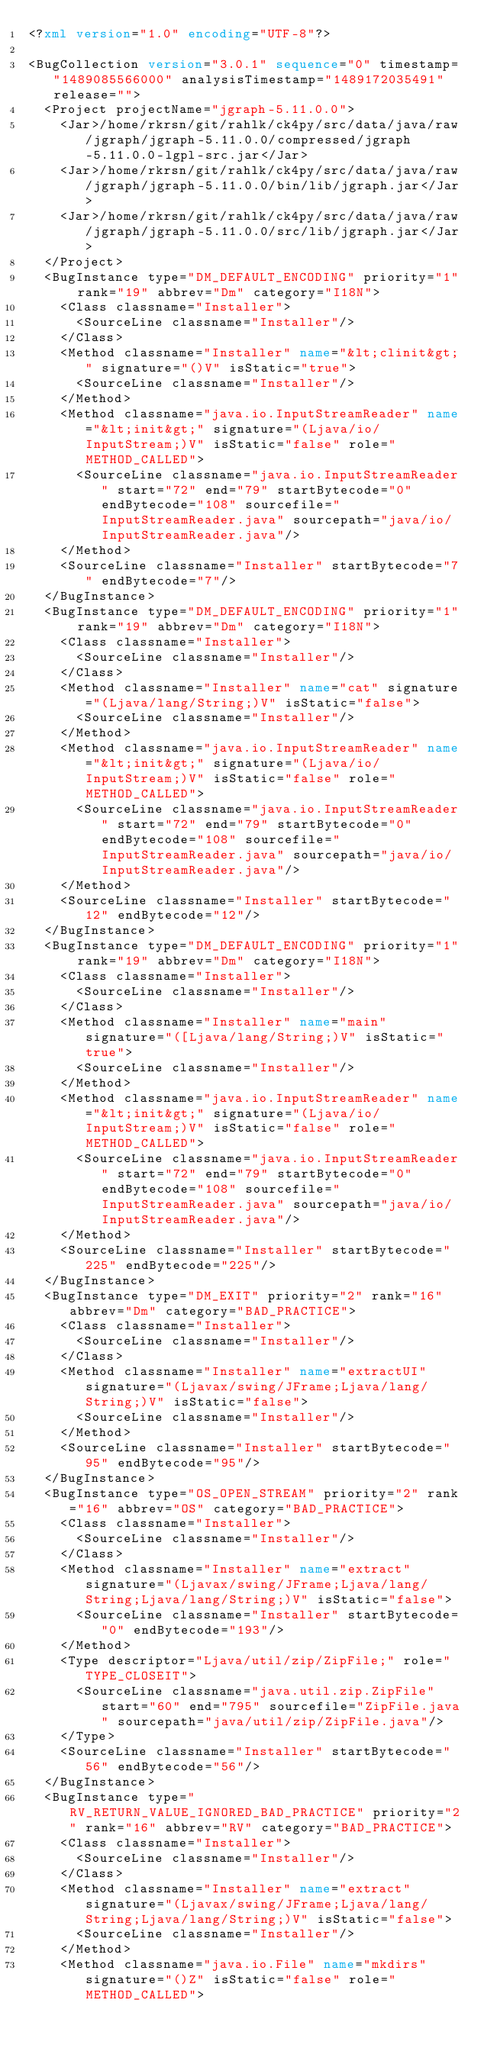Convert code to text. <code><loc_0><loc_0><loc_500><loc_500><_XML_><?xml version="1.0" encoding="UTF-8"?>

<BugCollection version="3.0.1" sequence="0" timestamp="1489085566000" analysisTimestamp="1489172035491" release="">
  <Project projectName="jgraph-5.11.0.0">
    <Jar>/home/rkrsn/git/rahlk/ck4py/src/data/java/raw/jgraph/jgraph-5.11.0.0/compressed/jgraph-5.11.0.0-lgpl-src.jar</Jar>
    <Jar>/home/rkrsn/git/rahlk/ck4py/src/data/java/raw/jgraph/jgraph-5.11.0.0/bin/lib/jgraph.jar</Jar>
    <Jar>/home/rkrsn/git/rahlk/ck4py/src/data/java/raw/jgraph/jgraph-5.11.0.0/src/lib/jgraph.jar</Jar>
  </Project>
  <BugInstance type="DM_DEFAULT_ENCODING" priority="1" rank="19" abbrev="Dm" category="I18N">
    <Class classname="Installer">
      <SourceLine classname="Installer"/>
    </Class>
    <Method classname="Installer" name="&lt;clinit&gt;" signature="()V" isStatic="true">
      <SourceLine classname="Installer"/>
    </Method>
    <Method classname="java.io.InputStreamReader" name="&lt;init&gt;" signature="(Ljava/io/InputStream;)V" isStatic="false" role="METHOD_CALLED">
      <SourceLine classname="java.io.InputStreamReader" start="72" end="79" startBytecode="0" endBytecode="108" sourcefile="InputStreamReader.java" sourcepath="java/io/InputStreamReader.java"/>
    </Method>
    <SourceLine classname="Installer" startBytecode="7" endBytecode="7"/>
  </BugInstance>
  <BugInstance type="DM_DEFAULT_ENCODING" priority="1" rank="19" abbrev="Dm" category="I18N">
    <Class classname="Installer">
      <SourceLine classname="Installer"/>
    </Class>
    <Method classname="Installer" name="cat" signature="(Ljava/lang/String;)V" isStatic="false">
      <SourceLine classname="Installer"/>
    </Method>
    <Method classname="java.io.InputStreamReader" name="&lt;init&gt;" signature="(Ljava/io/InputStream;)V" isStatic="false" role="METHOD_CALLED">
      <SourceLine classname="java.io.InputStreamReader" start="72" end="79" startBytecode="0" endBytecode="108" sourcefile="InputStreamReader.java" sourcepath="java/io/InputStreamReader.java"/>
    </Method>
    <SourceLine classname="Installer" startBytecode="12" endBytecode="12"/>
  </BugInstance>
  <BugInstance type="DM_DEFAULT_ENCODING" priority="1" rank="19" abbrev="Dm" category="I18N">
    <Class classname="Installer">
      <SourceLine classname="Installer"/>
    </Class>
    <Method classname="Installer" name="main" signature="([Ljava/lang/String;)V" isStatic="true">
      <SourceLine classname="Installer"/>
    </Method>
    <Method classname="java.io.InputStreamReader" name="&lt;init&gt;" signature="(Ljava/io/InputStream;)V" isStatic="false" role="METHOD_CALLED">
      <SourceLine classname="java.io.InputStreamReader" start="72" end="79" startBytecode="0" endBytecode="108" sourcefile="InputStreamReader.java" sourcepath="java/io/InputStreamReader.java"/>
    </Method>
    <SourceLine classname="Installer" startBytecode="225" endBytecode="225"/>
  </BugInstance>
  <BugInstance type="DM_EXIT" priority="2" rank="16" abbrev="Dm" category="BAD_PRACTICE">
    <Class classname="Installer">
      <SourceLine classname="Installer"/>
    </Class>
    <Method classname="Installer" name="extractUI" signature="(Ljavax/swing/JFrame;Ljava/lang/String;)V" isStatic="false">
      <SourceLine classname="Installer"/>
    </Method>
    <SourceLine classname="Installer" startBytecode="95" endBytecode="95"/>
  </BugInstance>
  <BugInstance type="OS_OPEN_STREAM" priority="2" rank="16" abbrev="OS" category="BAD_PRACTICE">
    <Class classname="Installer">
      <SourceLine classname="Installer"/>
    </Class>
    <Method classname="Installer" name="extract" signature="(Ljavax/swing/JFrame;Ljava/lang/String;Ljava/lang/String;)V" isStatic="false">
      <SourceLine classname="Installer" startBytecode="0" endBytecode="193"/>
    </Method>
    <Type descriptor="Ljava/util/zip/ZipFile;" role="TYPE_CLOSEIT">
      <SourceLine classname="java.util.zip.ZipFile" start="60" end="795" sourcefile="ZipFile.java" sourcepath="java/util/zip/ZipFile.java"/>
    </Type>
    <SourceLine classname="Installer" startBytecode="56" endBytecode="56"/>
  </BugInstance>
  <BugInstance type="RV_RETURN_VALUE_IGNORED_BAD_PRACTICE" priority="2" rank="16" abbrev="RV" category="BAD_PRACTICE">
    <Class classname="Installer">
      <SourceLine classname="Installer"/>
    </Class>
    <Method classname="Installer" name="extract" signature="(Ljavax/swing/JFrame;Ljava/lang/String;Ljava/lang/String;)V" isStatic="false">
      <SourceLine classname="Installer"/>
    </Method>
    <Method classname="java.io.File" name="mkdirs" signature="()Z" isStatic="false" role="METHOD_CALLED"></code> 